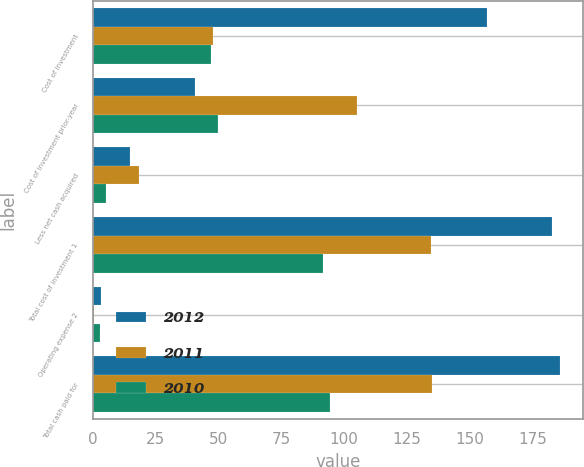Convert chart to OTSL. <chart><loc_0><loc_0><loc_500><loc_500><stacked_bar_chart><ecel><fcel>Cost of investment<fcel>Cost of investment prior-year<fcel>Less net cash acquired<fcel>Total cost of investment 1<fcel>Operating expense 2<fcel>Total cash paid for<nl><fcel>2012<fcel>156.8<fcel>40.6<fcel>14.8<fcel>182.6<fcel>3.2<fcel>185.8<nl><fcel>2011<fcel>48<fcel>105.1<fcel>18.5<fcel>134.6<fcel>0.5<fcel>135.1<nl><fcel>2010<fcel>47.1<fcel>49.6<fcel>5.3<fcel>91.4<fcel>3<fcel>94.4<nl></chart> 